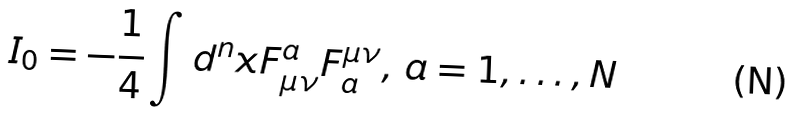Convert formula to latex. <formula><loc_0><loc_0><loc_500><loc_500>I _ { 0 } = - \frac { 1 } { 4 } \int d ^ { n } x F ^ { a } _ { \mu \nu } F ^ { \mu \nu } _ { a } , \, a = 1 , \dots , N</formula> 